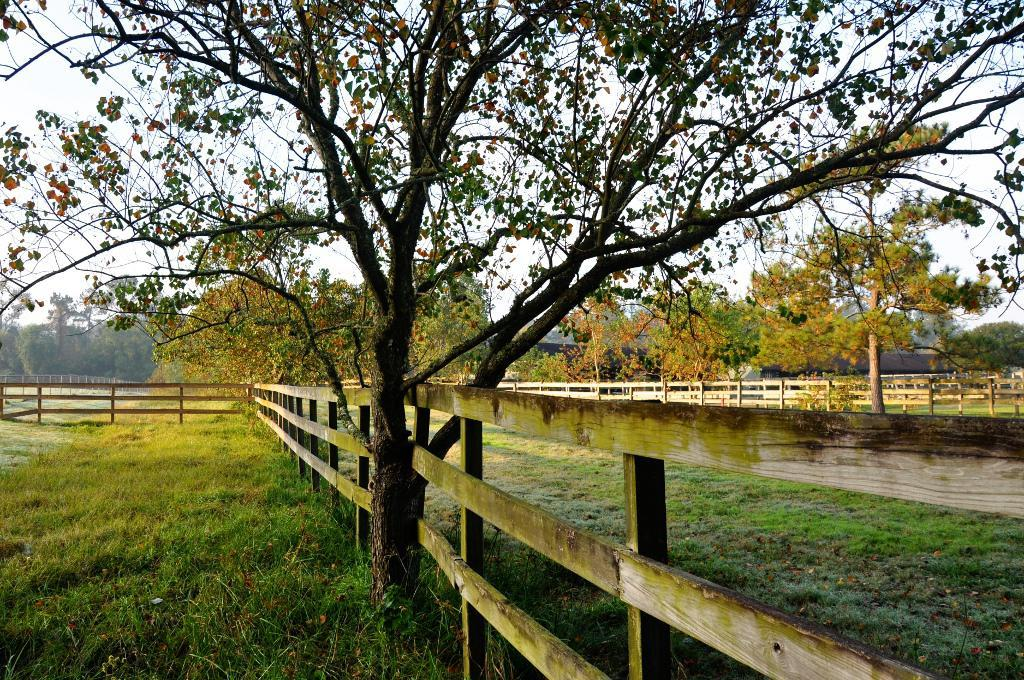What type of vegetation is present on the ground in the image? There is grass on the ground in the image. What type of structure can be seen in the image? There is a wooden railing in the image. What type of plant is visible in the image? There is a tree in the image. What can be seen in the distance in the image? Trees and the sky are visible in the background of the image. What word is being used to start a fight in the image? There is no fight or word present in the image. What type of coat is being worn by the tree in the image? There is no coat present in the image, as it features a tree and other natural elements. 